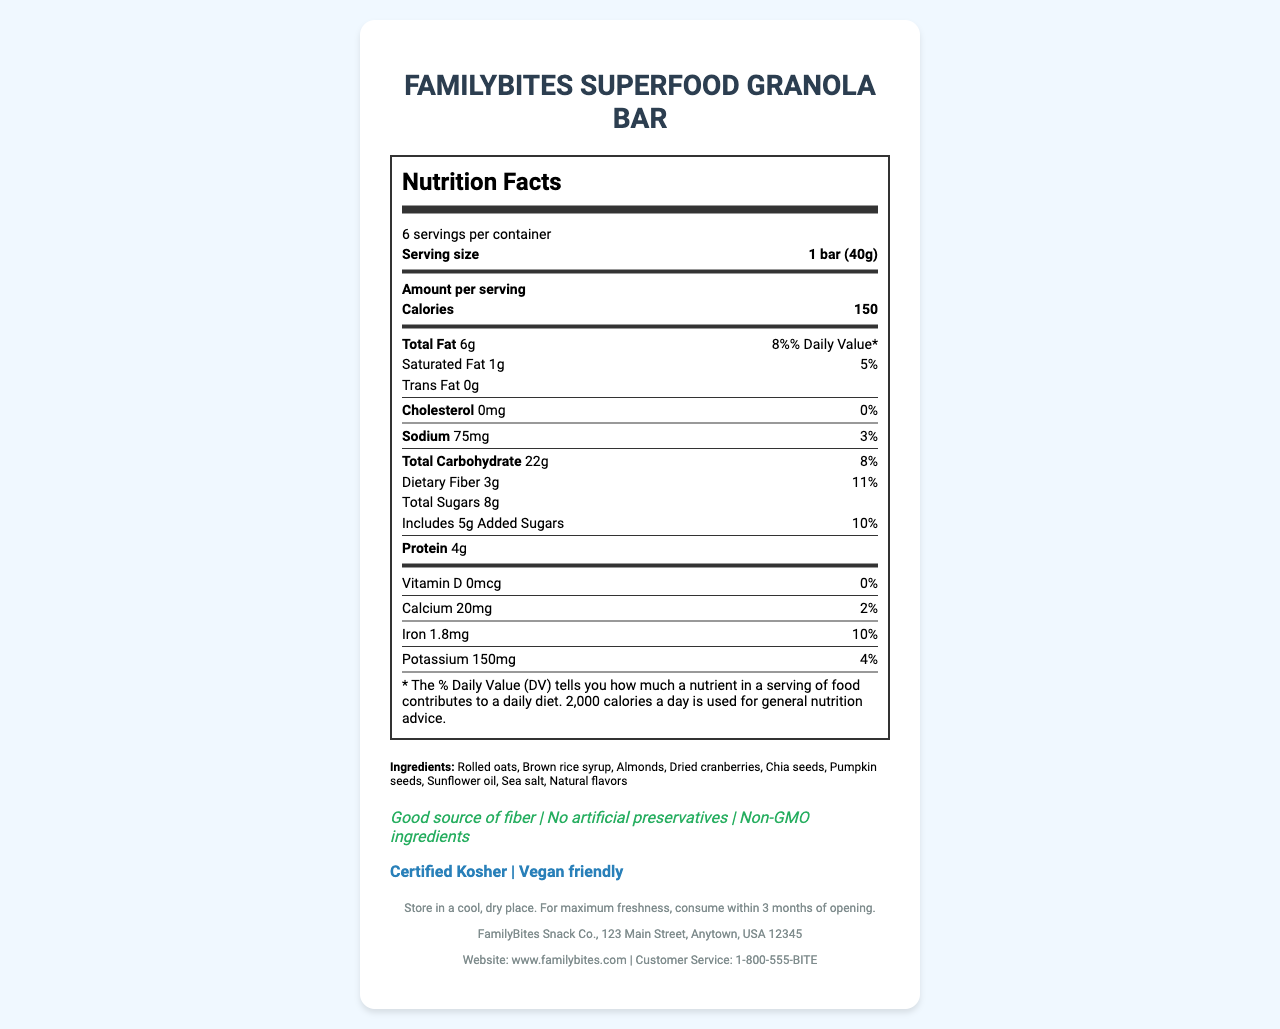What is the serving size for 'FamilyBites Superfood Granola Bar'? The serving size is listed as '1 bar (40g)' in the nutrition label section.
Answer: 1 bar (40g) How many servings are there per container? This information is mentioned at the top of the nutrition label section as '6 servings per container'.
Answer: 6 What is the calorie count per serving? The 'Calories' per serving is listed as '150' in the 'Amount per serving' section.
Answer: 150 How much total fat is in one serving? The total fat per serving is listed as '6g' with a daily value percentage of 8%.
Answer: 6g What are the allergens mentioned for this product? This information is found in the section listing allergens.
Answer: Contains almonds, May contain traces of other tree nuts and soy Which of the following nutrients is not present in this product? A. Cholesterol B. Protein C. Potassium Cholesterol is listed as '0mg' on the nutrition label, indicating it is not present.
Answer: A. Cholesterol What percentage of the daily value does dietary fiber contribute? A. 8% B. 10% C. 11% D. 3% The daily value contributed by dietary fiber is listed as 11%.
Answer: C. 11% What are the health claims made by 'FamilyBites Superfood Granola Bar'? This information is listed under the health claims section.
Answer: Good source of fiber, No artificial preservatives, Non-GMO ingredients Does this product contain any added sugars? The nutrition label lists 'Includes 5g Added Sugars', confirming the presence of added sugars.
Answer: Yes Is 'FamilyBites Superfood Granola Bar' vegan friendly? The certifications section mentions that the product is 'Vegan friendly'.
Answer: Yes Summarize the main idea of this document. The nutrition label gives comprehensive information about the serving size, calorie content, amounts of various nutrients, and the percentage of daily values they contribute. Additionally, it lists the ingredients, potential allergens, health claims like being a good source of fiber and containing non-GMO ingredients, and certifications such as being kosher and vegan friendly. Storage instructions and manufacturer information are also provided.
Answer: The document is a nutrition facts label for 'FamilyBites Superfood Granola Bar', detailing its nutritional content, ingredients, allergens, health claims, and certifications. It provides important dietary information, health benefits, and storage instructions for the product. How much potassium is in one serving, and what percentage of the daily value does it represent? The nutrition label states that each serving contains 150mg of potassium, which represents 4% of the daily value.
Answer: 150mg, 4% Name three ingredients in 'FamilyBites Superfood Granola Bar'. These ingredients are listed among the nine ingredients found in the ingredient section.
Answer: Rolled oats, Brown rice syrup, Almonds Does this product contain any saturated fat? The nutrition label lists the amount of saturated fat as '1g', indicating its presence.
Answer: Yes What is the address of the manufacturer? This address is provided under the manufacturer information section.
Answer: 123 Main Street, Anytown, USA 12345 What is the phone number for customer service? The customer service phone number is provided at the bottom of the document.
Answer: 1-800-555-BITE How should this product be stored? This storage instruction is provided at the bottom of the document.
Answer: Store in a cool, dry place. For maximum freshness, consume within 3 months of opening. What is the role of sea salt in the product? The document lists sea salt as an ingredient but does not provide details about its specific role or function in the product.
Answer: Cannot be determined 